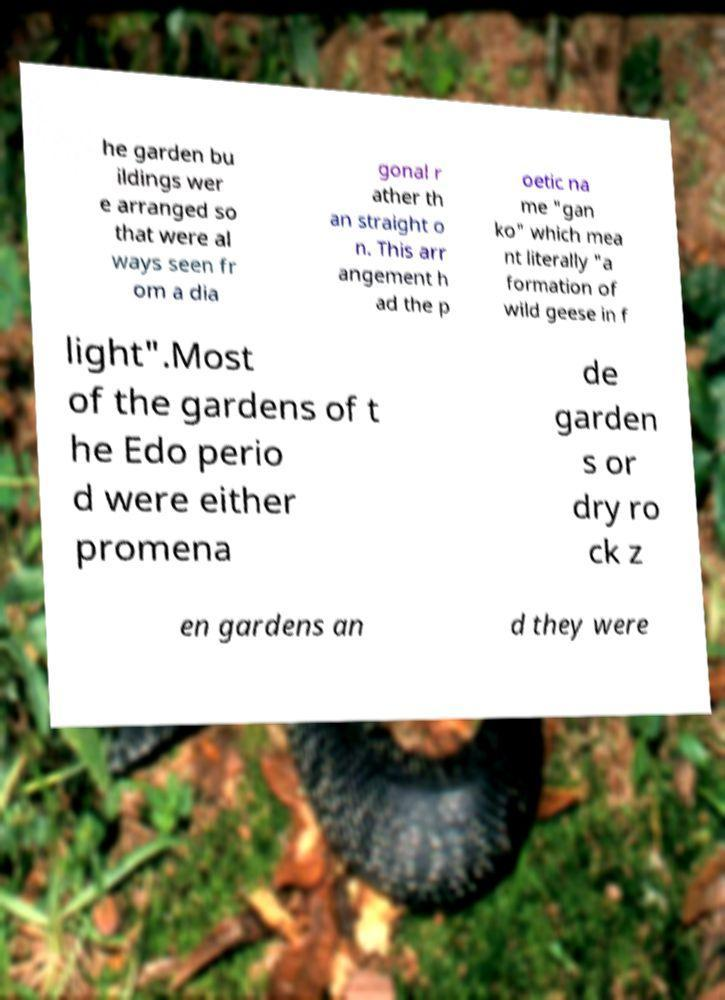I need the written content from this picture converted into text. Can you do that? he garden bu ildings wer e arranged so that were al ways seen fr om a dia gonal r ather th an straight o n. This arr angement h ad the p oetic na me "gan ko" which mea nt literally "a formation of wild geese in f light".Most of the gardens of t he Edo perio d were either promena de garden s or dry ro ck z en gardens an d they were 